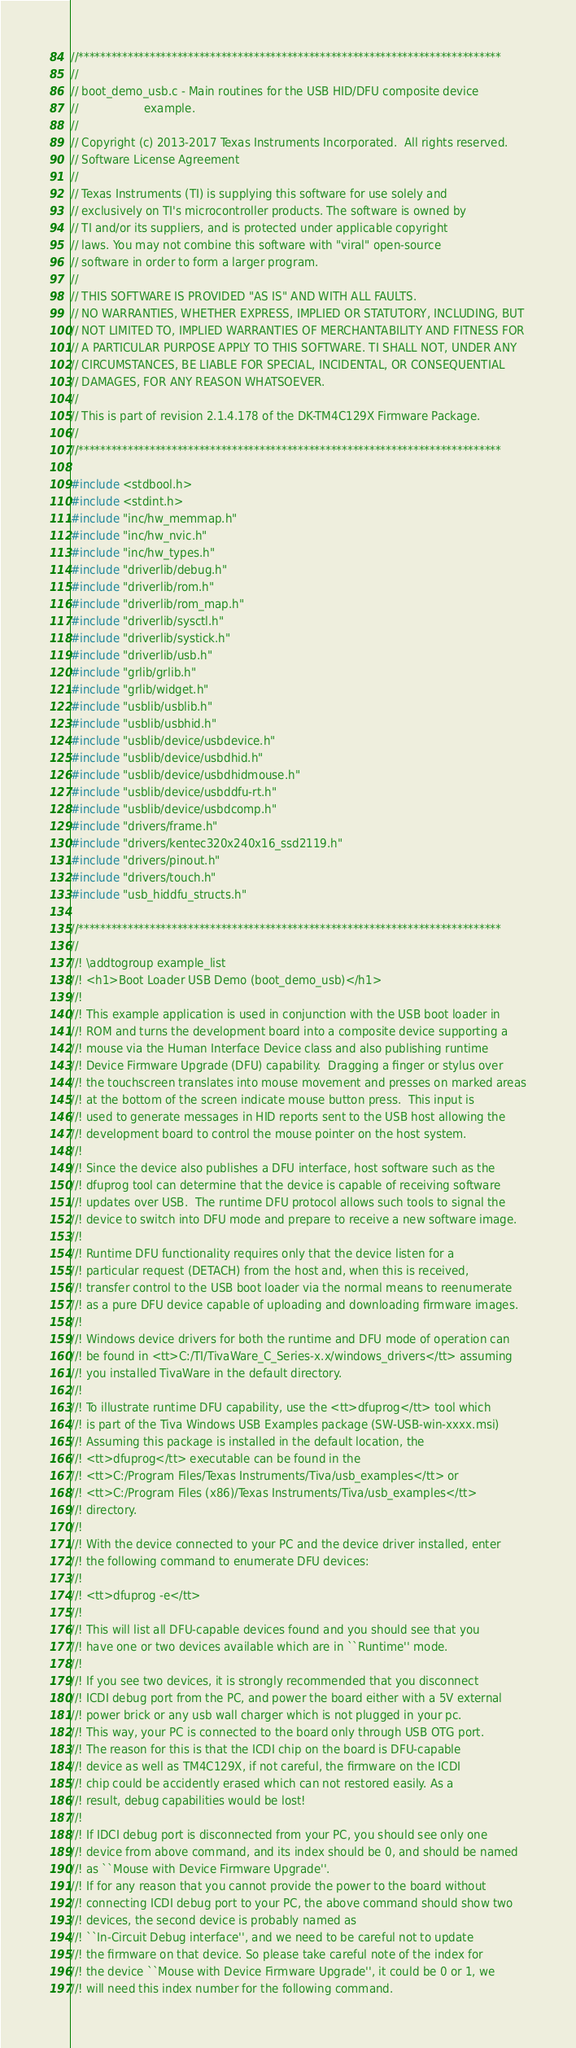Convert code to text. <code><loc_0><loc_0><loc_500><loc_500><_C_>//*****************************************************************************
//
// boot_demo_usb.c - Main routines for the USB HID/DFU composite device
//                   example.
//
// Copyright (c) 2013-2017 Texas Instruments Incorporated.  All rights reserved.
// Software License Agreement
// 
// Texas Instruments (TI) is supplying this software for use solely and
// exclusively on TI's microcontroller products. The software is owned by
// TI and/or its suppliers, and is protected under applicable copyright
// laws. You may not combine this software with "viral" open-source
// software in order to form a larger program.
// 
// THIS SOFTWARE IS PROVIDED "AS IS" AND WITH ALL FAULTS.
// NO WARRANTIES, WHETHER EXPRESS, IMPLIED OR STATUTORY, INCLUDING, BUT
// NOT LIMITED TO, IMPLIED WARRANTIES OF MERCHANTABILITY AND FITNESS FOR
// A PARTICULAR PURPOSE APPLY TO THIS SOFTWARE. TI SHALL NOT, UNDER ANY
// CIRCUMSTANCES, BE LIABLE FOR SPECIAL, INCIDENTAL, OR CONSEQUENTIAL
// DAMAGES, FOR ANY REASON WHATSOEVER.
// 
// This is part of revision 2.1.4.178 of the DK-TM4C129X Firmware Package.
//
//*****************************************************************************

#include <stdbool.h>
#include <stdint.h>
#include "inc/hw_memmap.h"
#include "inc/hw_nvic.h"
#include "inc/hw_types.h"
#include "driverlib/debug.h"
#include "driverlib/rom.h"
#include "driverlib/rom_map.h"
#include "driverlib/sysctl.h"
#include "driverlib/systick.h"
#include "driverlib/usb.h"
#include "grlib/grlib.h"
#include "grlib/widget.h"
#include "usblib/usblib.h"
#include "usblib/usbhid.h"
#include "usblib/device/usbdevice.h"
#include "usblib/device/usbdhid.h"
#include "usblib/device/usbdhidmouse.h"
#include "usblib/device/usbddfu-rt.h"
#include "usblib/device/usbdcomp.h"
#include "drivers/frame.h"
#include "drivers/kentec320x240x16_ssd2119.h"
#include "drivers/pinout.h"
#include "drivers/touch.h"
#include "usb_hiddfu_structs.h"

//*****************************************************************************
//
//! \addtogroup example_list
//! <h1>Boot Loader USB Demo (boot_demo_usb)</h1>
//!
//! This example application is used in conjunction with the USB boot loader in
//! ROM and turns the development board into a composite device supporting a
//! mouse via the Human Interface Device class and also publishing runtime
//! Device Firmware Upgrade (DFU) capability.  Dragging a finger or stylus over
//! the touchscreen translates into mouse movement and presses on marked areas
//! at the bottom of the screen indicate mouse button press.  This input is
//! used to generate messages in HID reports sent to the USB host allowing the
//! development board to control the mouse pointer on the host system.
//!
//! Since the device also publishes a DFU interface, host software such as the
//! dfuprog tool can determine that the device is capable of receiving software
//! updates over USB.  The runtime DFU protocol allows such tools to signal the
//! device to switch into DFU mode and prepare to receive a new software image.
//!
//! Runtime DFU functionality requires only that the device listen for a
//! particular request (DETACH) from the host and, when this is received,
//! transfer control to the USB boot loader via the normal means to reenumerate
//! as a pure DFU device capable of uploading and downloading firmware images.
//!
//! Windows device drivers for both the runtime and DFU mode of operation can
//! be found in <tt>C:/TI/TivaWare_C_Series-x.x/windows_drivers</tt> assuming
//! you installed TivaWare in the default directory.
//!
//! To illustrate runtime DFU capability, use the <tt>dfuprog</tt> tool which
//! is part of the Tiva Windows USB Examples package (SW-USB-win-xxxx.msi)
//! Assuming this package is installed in the default location, the
//! <tt>dfuprog</tt> executable can be found in the
//! <tt>C:/Program Files/Texas Instruments/Tiva/usb_examples</tt> or 
//! <tt>C:/Program Files (x86)/Texas Instruments/Tiva/usb_examples</tt>
//! directory.
//!
//! With the device connected to your PC and the device driver installed, enter
//! the following command to enumerate DFU devices:
//!
//! <tt>dfuprog -e</tt>
//!
//! This will list all DFU-capable devices found and you should see that you
//! have one or two devices available which are in ``Runtime'' mode.
//!
//! If you see two devices, it is strongly recommended that you disconnect
//! ICDI debug port from the PC, and power the board either with a 5V external
//! power brick or any usb wall charger which is not plugged in your pc.
//! This way, your PC is connected to the board only through USB OTG port. 
//! The reason for this is that the ICDI chip on the board is DFU-capable
//! device as well as TM4C129X, if not careful, the firmware on the ICDI
//! chip could be accidently erased which can not restored easily. As a
//! result, debug capabilities would be lost!
//!
//! If IDCI debug port is disconnected from your PC, you should see only one
//! device from above command, and its index should be 0, and should be named
//! as ``Mouse with Device Firmware Upgrade''. 
//! If for any reason that you cannot provide the power to the board without
//! connecting ICDI debug port to your PC, the above command should show two
//! devices, the second device is probably named as
//! ``In-Circuit Debug interface'', and we need to be careful not to update
//! the firmware on that device. So please take careful note of the index for
//! the device ``Mouse with Device Firmware Upgrade'', it could be 0 or 1, we
//! will need this index number for the following command. </code> 